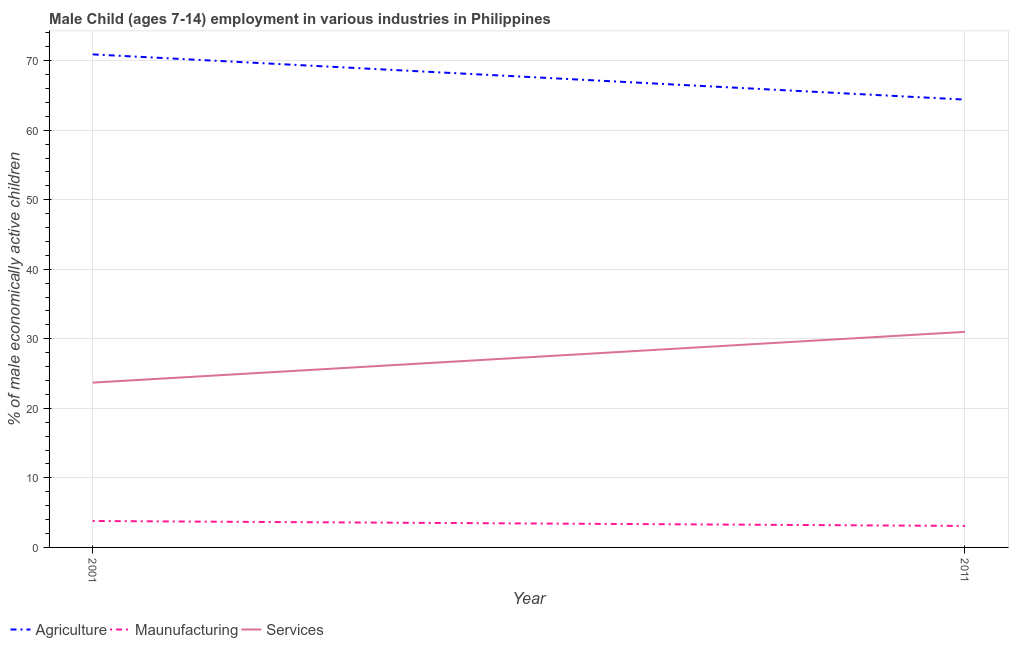How many different coloured lines are there?
Make the answer very short. 3. What is the percentage of economically active children in services in 2011?
Your response must be concise. 31. Across all years, what is the maximum percentage of economically active children in services?
Provide a succinct answer. 31. Across all years, what is the minimum percentage of economically active children in manufacturing?
Your response must be concise. 3.09. In which year was the percentage of economically active children in manufacturing maximum?
Your answer should be compact. 2001. What is the total percentage of economically active children in agriculture in the graph?
Provide a succinct answer. 135.3. What is the difference between the percentage of economically active children in services in 2001 and that in 2011?
Keep it short and to the point. -7.3. What is the difference between the percentage of economically active children in manufacturing in 2011 and the percentage of economically active children in agriculture in 2001?
Offer a terse response. -67.81. What is the average percentage of economically active children in agriculture per year?
Keep it short and to the point. 67.65. In the year 2011, what is the difference between the percentage of economically active children in manufacturing and percentage of economically active children in services?
Make the answer very short. -27.91. In how many years, is the percentage of economically active children in manufacturing greater than 40 %?
Provide a short and direct response. 0. What is the ratio of the percentage of economically active children in agriculture in 2001 to that in 2011?
Your response must be concise. 1.1. Is the percentage of economically active children in manufacturing in 2001 less than that in 2011?
Ensure brevity in your answer.  No. Does the percentage of economically active children in agriculture monotonically increase over the years?
Your answer should be very brief. No. Is the percentage of economically active children in agriculture strictly greater than the percentage of economically active children in manufacturing over the years?
Give a very brief answer. Yes. How many lines are there?
Your answer should be very brief. 3. How many years are there in the graph?
Provide a succinct answer. 2. Are the values on the major ticks of Y-axis written in scientific E-notation?
Offer a very short reply. No. Does the graph contain grids?
Your answer should be very brief. Yes. Where does the legend appear in the graph?
Offer a terse response. Bottom left. How many legend labels are there?
Keep it short and to the point. 3. What is the title of the graph?
Give a very brief answer. Male Child (ages 7-14) employment in various industries in Philippines. What is the label or title of the Y-axis?
Keep it short and to the point. % of male economically active children. What is the % of male economically active children of Agriculture in 2001?
Your answer should be very brief. 70.9. What is the % of male economically active children of Maunufacturing in 2001?
Your response must be concise. 3.8. What is the % of male economically active children of Services in 2001?
Your answer should be very brief. 23.7. What is the % of male economically active children of Agriculture in 2011?
Provide a succinct answer. 64.4. What is the % of male economically active children in Maunufacturing in 2011?
Keep it short and to the point. 3.09. What is the % of male economically active children in Services in 2011?
Offer a terse response. 31. Across all years, what is the maximum % of male economically active children in Agriculture?
Give a very brief answer. 70.9. Across all years, what is the minimum % of male economically active children of Agriculture?
Your response must be concise. 64.4. Across all years, what is the minimum % of male economically active children in Maunufacturing?
Make the answer very short. 3.09. Across all years, what is the minimum % of male economically active children in Services?
Provide a succinct answer. 23.7. What is the total % of male economically active children of Agriculture in the graph?
Make the answer very short. 135.3. What is the total % of male economically active children in Maunufacturing in the graph?
Offer a terse response. 6.89. What is the total % of male economically active children of Services in the graph?
Your response must be concise. 54.7. What is the difference between the % of male economically active children of Maunufacturing in 2001 and that in 2011?
Offer a terse response. 0.71. What is the difference between the % of male economically active children in Services in 2001 and that in 2011?
Offer a terse response. -7.3. What is the difference between the % of male economically active children in Agriculture in 2001 and the % of male economically active children in Maunufacturing in 2011?
Ensure brevity in your answer.  67.81. What is the difference between the % of male economically active children of Agriculture in 2001 and the % of male economically active children of Services in 2011?
Offer a terse response. 39.9. What is the difference between the % of male economically active children in Maunufacturing in 2001 and the % of male economically active children in Services in 2011?
Provide a succinct answer. -27.2. What is the average % of male economically active children in Agriculture per year?
Your answer should be compact. 67.65. What is the average % of male economically active children in Maunufacturing per year?
Provide a succinct answer. 3.44. What is the average % of male economically active children in Services per year?
Give a very brief answer. 27.35. In the year 2001, what is the difference between the % of male economically active children in Agriculture and % of male economically active children in Maunufacturing?
Keep it short and to the point. 67.1. In the year 2001, what is the difference between the % of male economically active children in Agriculture and % of male economically active children in Services?
Offer a very short reply. 47.2. In the year 2001, what is the difference between the % of male economically active children of Maunufacturing and % of male economically active children of Services?
Your answer should be compact. -19.9. In the year 2011, what is the difference between the % of male economically active children in Agriculture and % of male economically active children in Maunufacturing?
Keep it short and to the point. 61.31. In the year 2011, what is the difference between the % of male economically active children in Agriculture and % of male economically active children in Services?
Make the answer very short. 33.4. In the year 2011, what is the difference between the % of male economically active children of Maunufacturing and % of male economically active children of Services?
Your answer should be very brief. -27.91. What is the ratio of the % of male economically active children of Agriculture in 2001 to that in 2011?
Ensure brevity in your answer.  1.1. What is the ratio of the % of male economically active children of Maunufacturing in 2001 to that in 2011?
Provide a short and direct response. 1.23. What is the ratio of the % of male economically active children of Services in 2001 to that in 2011?
Your answer should be very brief. 0.76. What is the difference between the highest and the second highest % of male economically active children of Maunufacturing?
Your answer should be very brief. 0.71. What is the difference between the highest and the lowest % of male economically active children in Maunufacturing?
Your answer should be compact. 0.71. What is the difference between the highest and the lowest % of male economically active children of Services?
Keep it short and to the point. 7.3. 